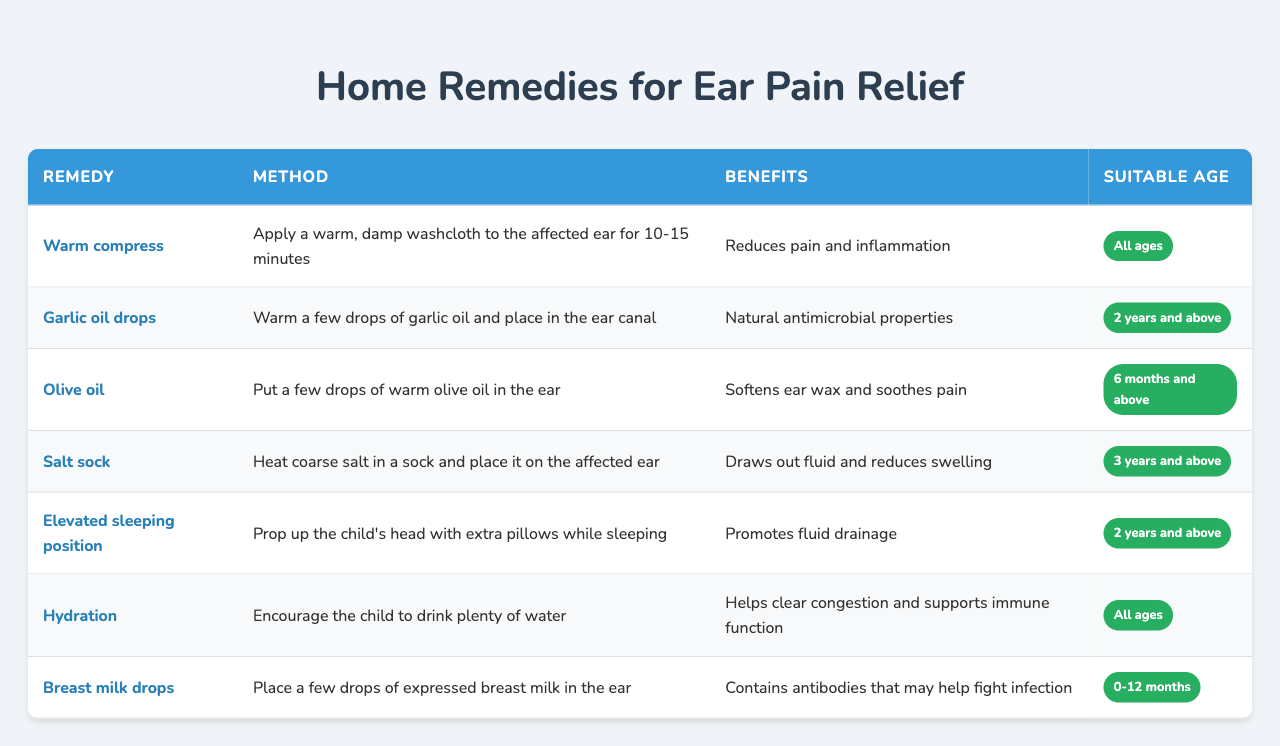What is the method for using garlic oil drops? The table states that garlic oil drops involve warming a few drops of garlic oil and placing them in the ear canal.
Answer: Warm garlic oil and place in ear What are the benefits of using a warm compress? According to the table, a warm compress reduces pain and inflammation when applied to the affected ear for 10-15 minutes.
Answer: Reduces pain and inflammation Is the "salt sock" remedy suitable for infants? The table indicates that the salt sock remedy is suitable for children aged 3 years and above, so it is not suitable for infants.
Answer: No How many remedies are suitable for all ages? The table lists two remedies that are suitable for all ages: warm compress and hydration, making a total of 2.
Answer: 2 If a child is 1 year old, what remedies can be used? The remedies suitable for a 1-year-old are warm compress, olive oil, hydration, and breast milk drops, totaling 4 options.
Answer: 4 remedies Which remedy is recommended for children with ear pain and also contains natural antimicrobial properties? Garlic oil drops are identified in the table as having natural antimicrobial properties and are recommended for ear pain relief.
Answer: Garlic oil drops What is the benefit of placing a few drops of expressed breast milk in the ear? The table states that placing expressed breast milk in the ear may help fight infection due to its antibodies.
Answer: Helps fight infection What is the method for the "elevated sleeping position" remedy? The table states that to use the elevated sleeping position remedy, you should prop up the child's head with extra pillows while sleeping.
Answer: Prop head up with pillows Which remedy helps to clear congestion and supports immune function? The table shows that hydration, by encouraging the child to drink plenty of water, helps clear congestion and supports immune function.
Answer: Hydration Are olive oil and garlic oil drops recommended for the same age group? Based on the table, olive oil is suitable for children aged 6 months and above, while garlic oil drops are for children 2 years and above, indicating they are not recommended for the same age group.
Answer: No 